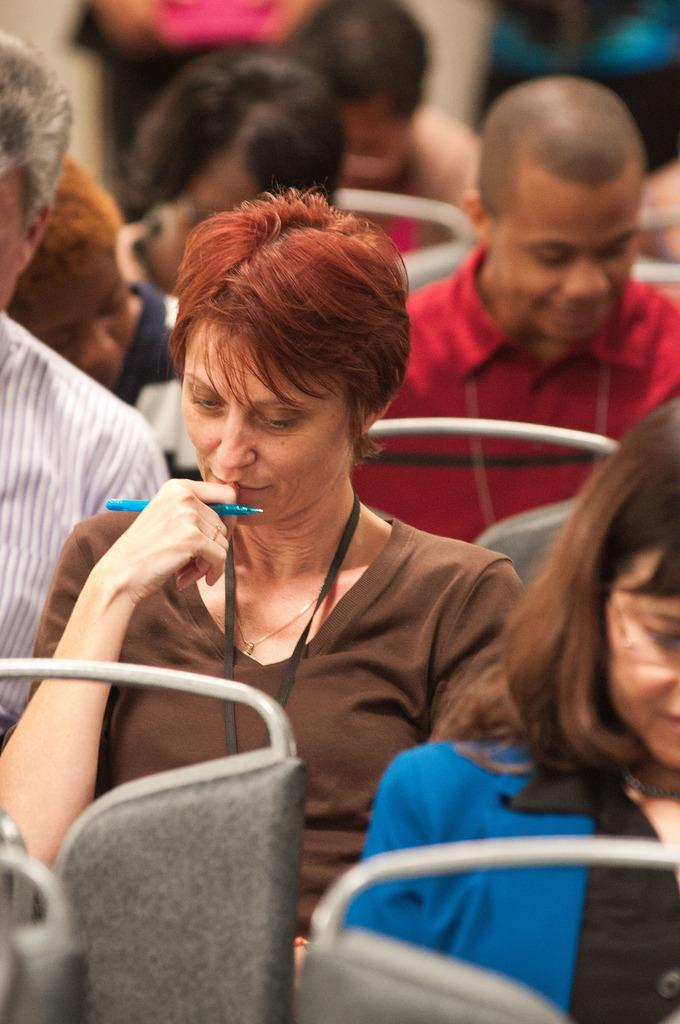How many people are in the image? There is a group of people in the image. What are the people doing in the image? The people are sitting on chairs. Can you describe the person holding an object in the image? There is a person holding a pen in the image. What can be said about the background of the image? The background of the image is blurred. What type of owl can be seen sitting on the canvas in the image? There is no owl or canvas present in the image. What is the person holding a pen writing on their stomach in the image? There is no person holding a pen writing on their stomach in the image. 